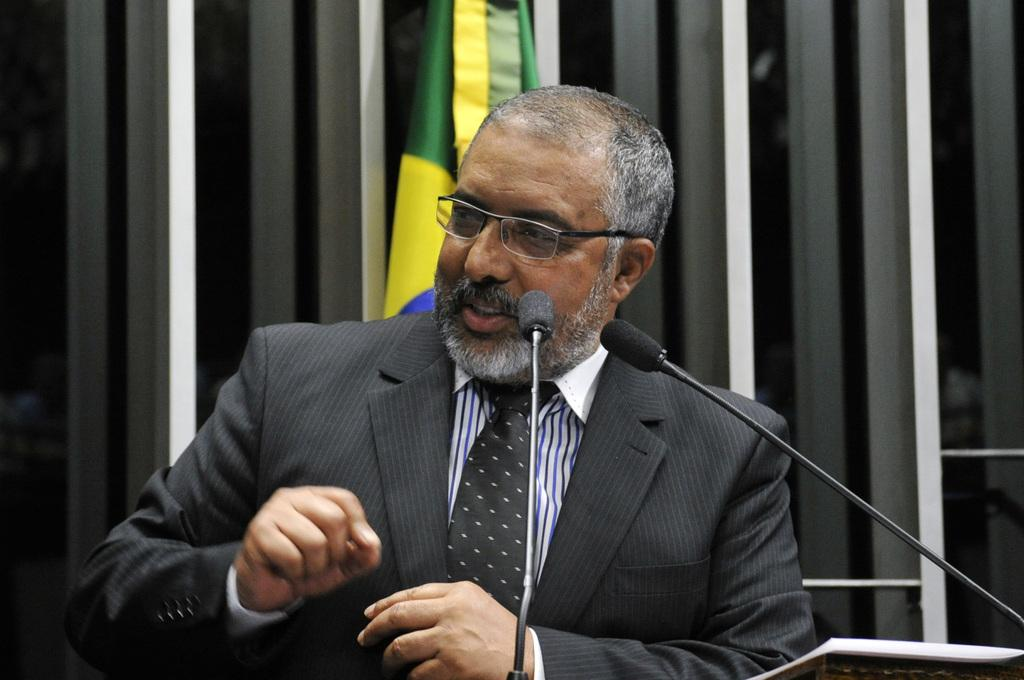Who is the main subject in the image? There is a man in the center of the image. What is the man doing in the image? The man is speaking on a microphone. Where is the microphone positioned in relation to the man? The microphone is in front of the man. What can be seen in the background of the image? There is a flag and windows in the background of the image. What type of trail can be seen in the image? There is no trail present in the image. What achievement has the man accomplished, as indicated by the flag in the background? The image does not provide any information about the man's achievements or the significance of the flag. 